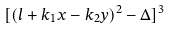<formula> <loc_0><loc_0><loc_500><loc_500>[ ( l + k _ { 1 } x - k _ { 2 } y ) ^ { 2 } - \Delta ] ^ { 3 }</formula> 